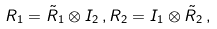<formula> <loc_0><loc_0><loc_500><loc_500>R _ { 1 } = \tilde { R } _ { 1 } \otimes I _ { 2 } \, , R _ { 2 } = I _ { 1 } \otimes \tilde { R } _ { 2 } \, ,</formula> 